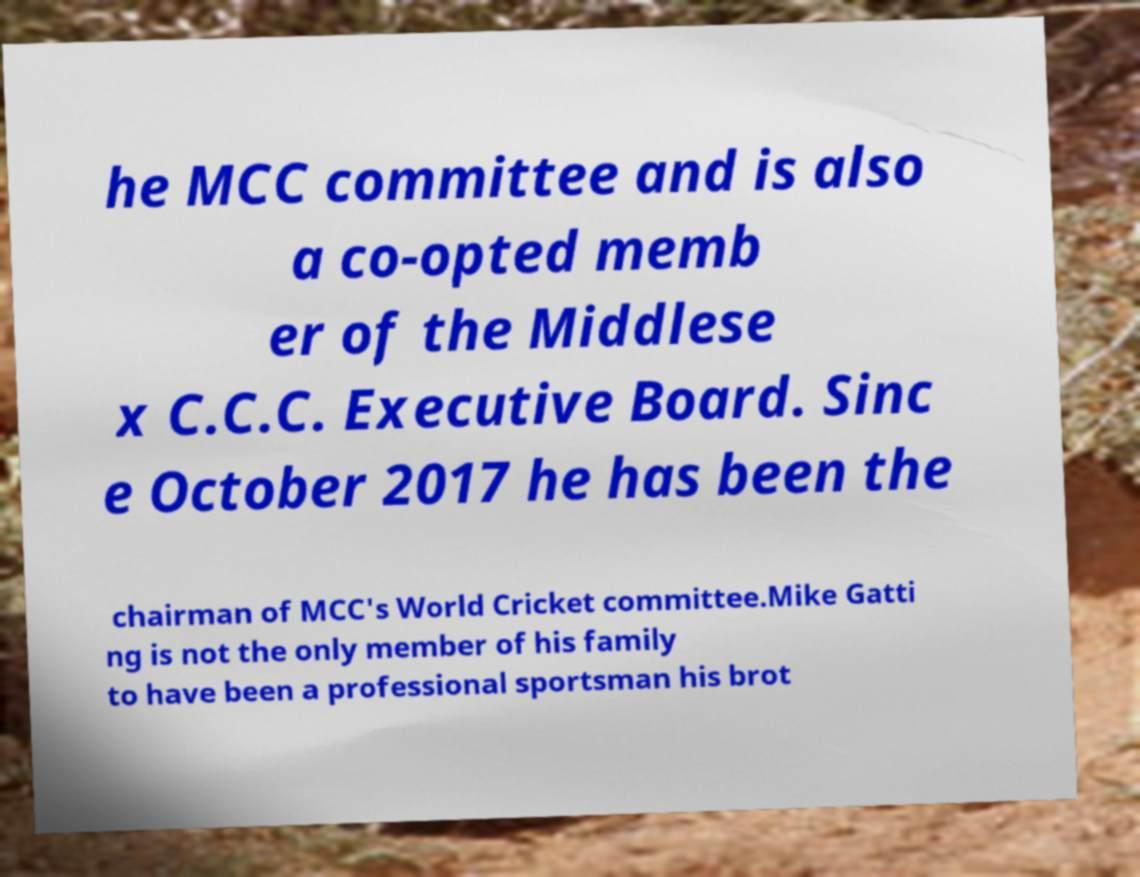Could you extract and type out the text from this image? he MCC committee and is also a co-opted memb er of the Middlese x C.C.C. Executive Board. Sinc e October 2017 he has been the chairman of MCC's World Cricket committee.Mike Gatti ng is not the only member of his family to have been a professional sportsman his brot 